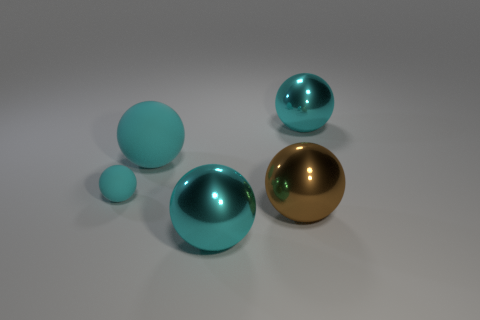How many cyan balls must be subtracted to get 2 cyan balls? 2 Subtract all gray cubes. How many cyan spheres are left? 4 Subtract 2 spheres. How many spheres are left? 3 Subtract all brown spheres. How many spheres are left? 4 Subtract all large rubber spheres. How many spheres are left? 4 Subtract all blue spheres. Subtract all green cubes. How many spheres are left? 5 Add 5 small green shiny objects. How many objects exist? 10 Add 2 large brown objects. How many large brown objects exist? 3 Subtract 0 gray balls. How many objects are left? 5 Subtract all big brown shiny things. Subtract all cyan shiny balls. How many objects are left? 2 